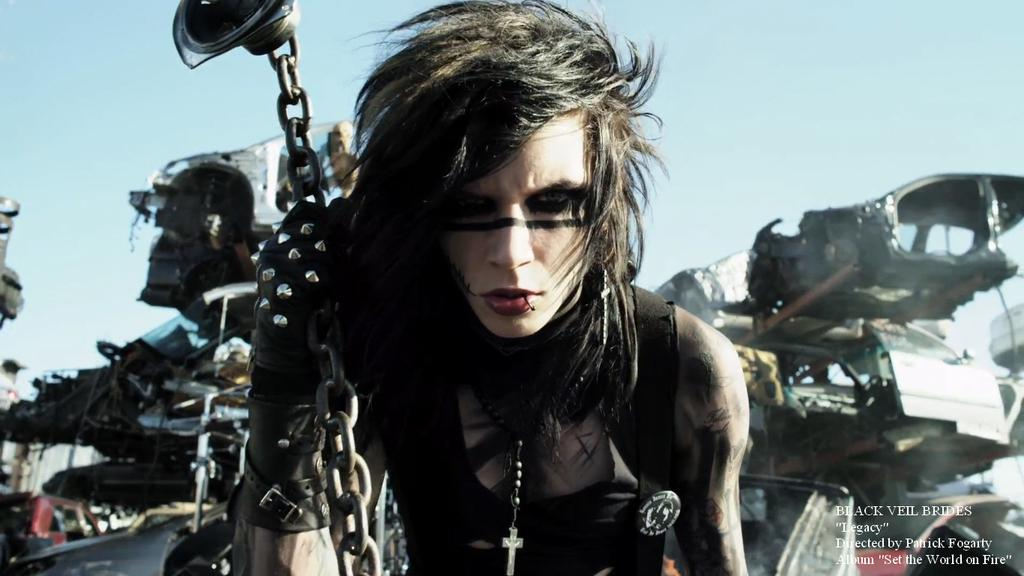Who or what is the main subject in the image? There is a person in the center of the image. What is the person holding in the image? The person is holding a chain. What can be seen in the background of the image? There is a scrap in the background of the image. What type of tree can be seen in the background of the image? There is no tree present in the image; it features a person holding a chain and a scrap in the background. 